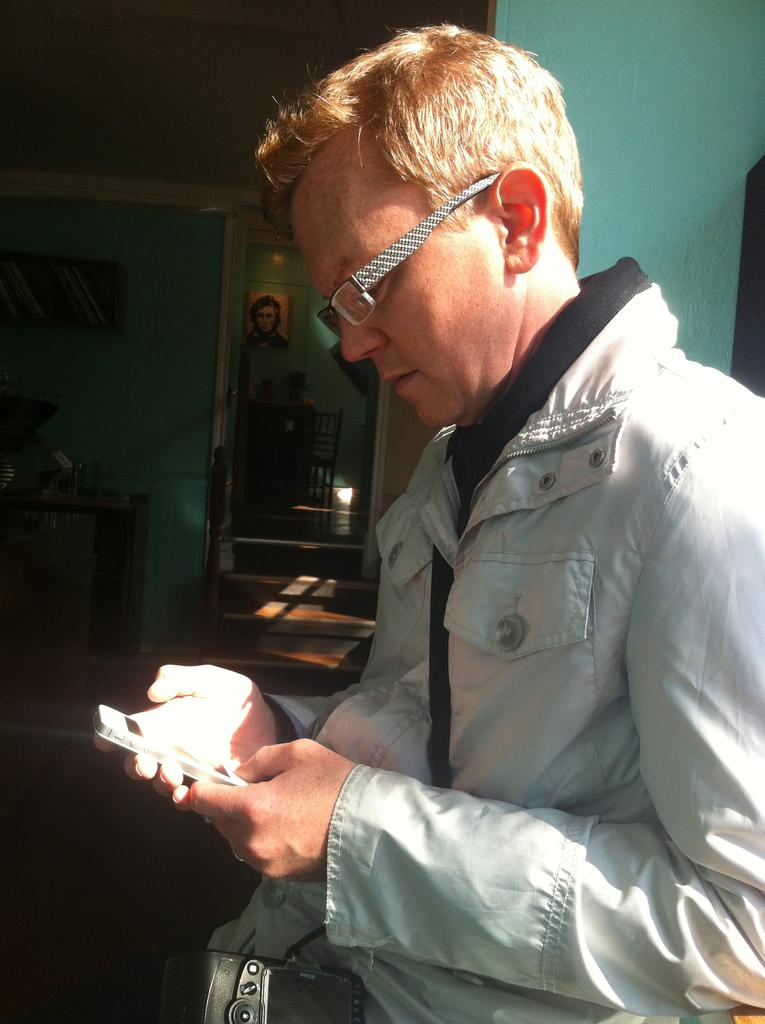What is the man in the image doing? The man is holding a mobile and looking at it. What is the man holding in the image? The man is holding a mobile. What can be seen on the wall in the image? There is a picture on the wall. What type of storage is visible in the image? There are books in a rack. What is present on the table in the image? There are objects on a table. What type of furniture is in the distance in the image? There is a chair in the distance in the distance. Reasoning: Let's think step by following the guidelines to produce the conversation. We start by identifying the main subject in the image, which is the man. Then, we describe what the man is doing and holding. Next, we mention other objects and elements in the image, such as the picture on the wall, the books in a rack, the objects on the table, and the chair in the distance. Each question is designed to elicit a specific detail about the image that is known from the provided facts. Absurd Question/Answer: How much money is on the ground in the image? There is no money on the ground in the image. What type of theory is the man discussing with the mobile in the image? The image does not show the man discussing any theory; he is simply holding and looking at the mobile. 